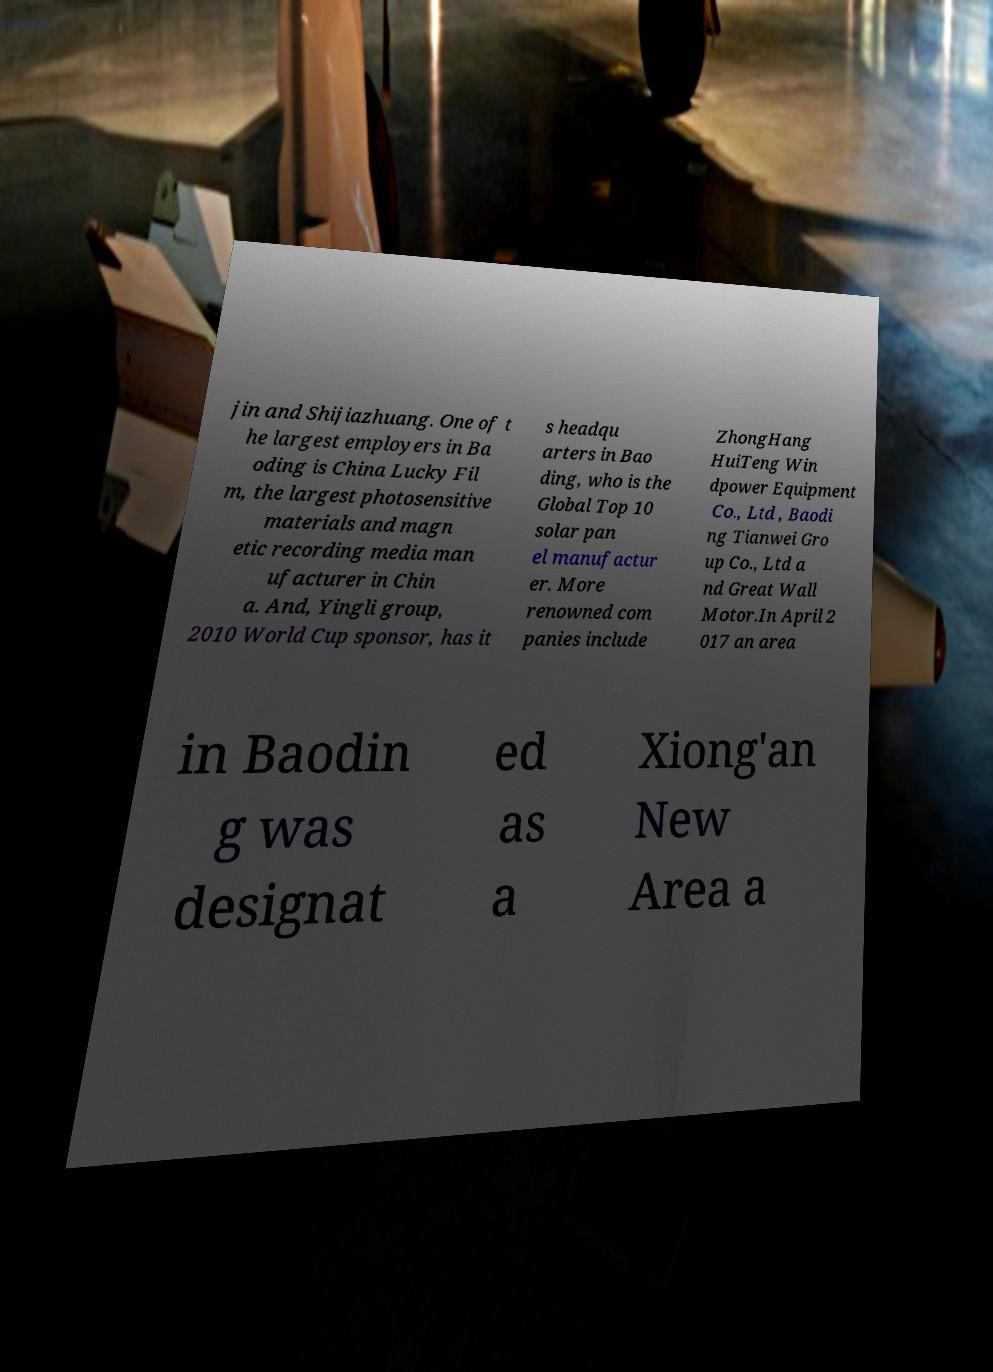Please identify and transcribe the text found in this image. jin and Shijiazhuang. One of t he largest employers in Ba oding is China Lucky Fil m, the largest photosensitive materials and magn etic recording media man ufacturer in Chin a. And, Yingli group, 2010 World Cup sponsor, has it s headqu arters in Bao ding, who is the Global Top 10 solar pan el manufactur er. More renowned com panies include ZhongHang HuiTeng Win dpower Equipment Co., Ltd , Baodi ng Tianwei Gro up Co., Ltd a nd Great Wall Motor.In April 2 017 an area in Baodin g was designat ed as a Xiong'an New Area a 